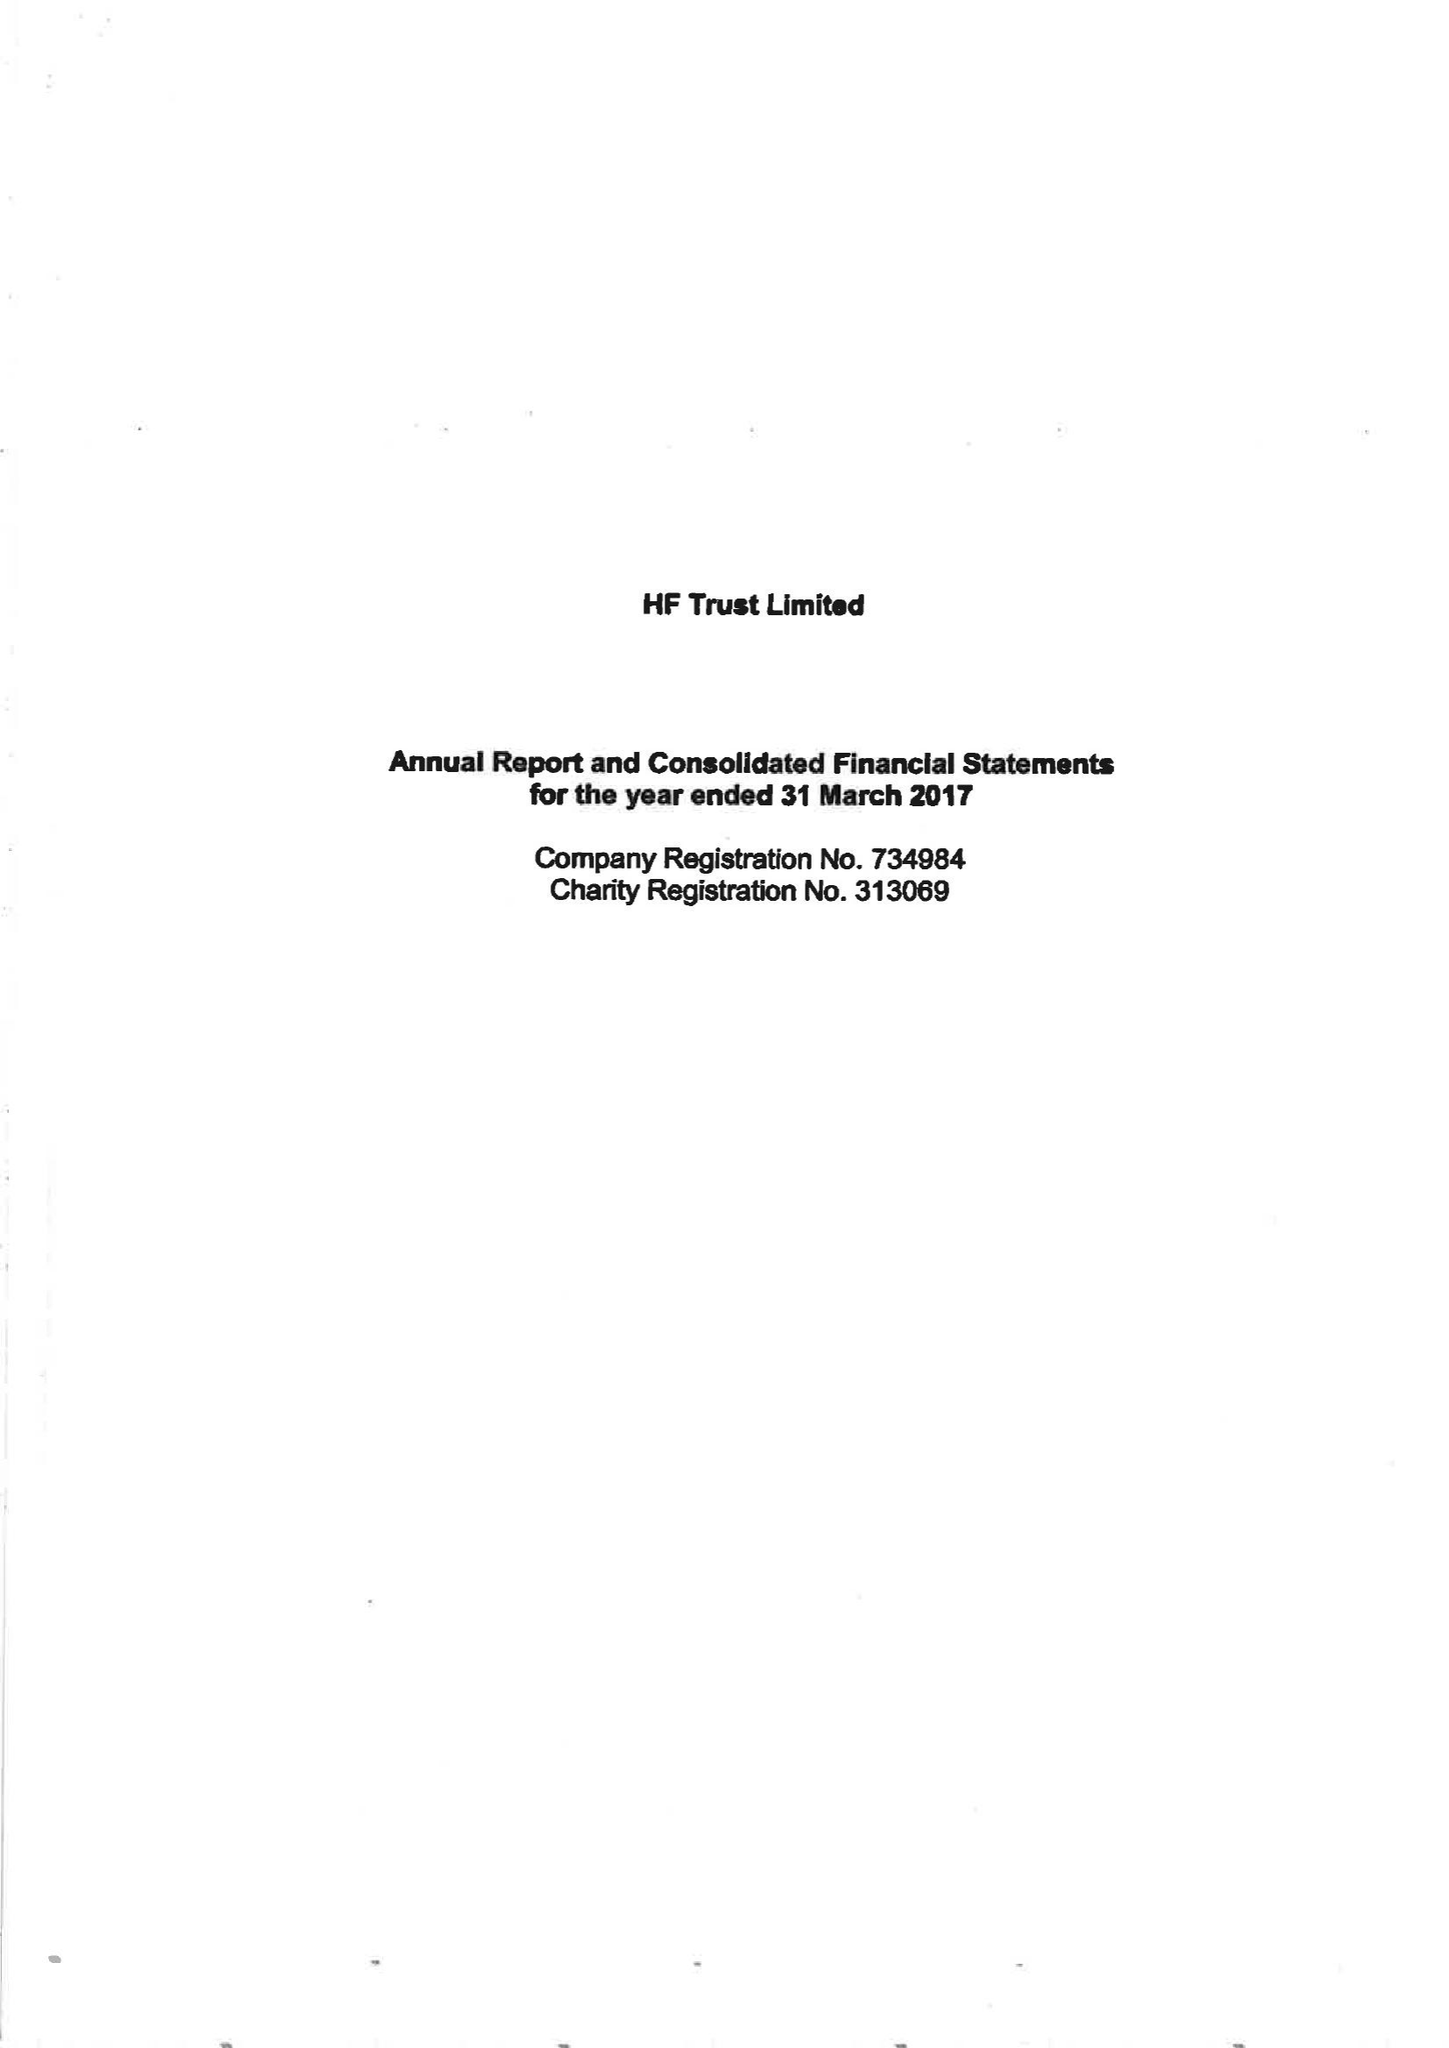What is the value for the address__street_line?
Answer the question using a single word or phrase. FOLLY BROOK ROAD 